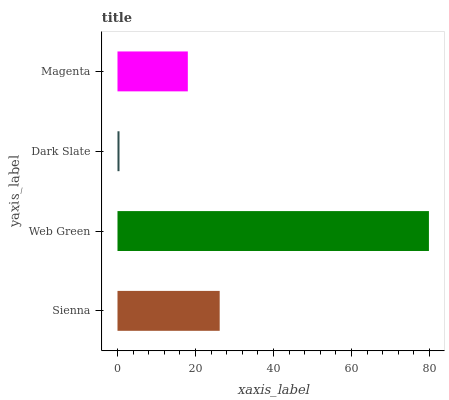Is Dark Slate the minimum?
Answer yes or no. Yes. Is Web Green the maximum?
Answer yes or no. Yes. Is Web Green the minimum?
Answer yes or no. No. Is Dark Slate the maximum?
Answer yes or no. No. Is Web Green greater than Dark Slate?
Answer yes or no. Yes. Is Dark Slate less than Web Green?
Answer yes or no. Yes. Is Dark Slate greater than Web Green?
Answer yes or no. No. Is Web Green less than Dark Slate?
Answer yes or no. No. Is Sienna the high median?
Answer yes or no. Yes. Is Magenta the low median?
Answer yes or no. Yes. Is Web Green the high median?
Answer yes or no. No. Is Web Green the low median?
Answer yes or no. No. 